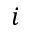Convert formula to latex. <formula><loc_0><loc_0><loc_500><loc_500>i</formula> 